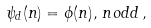Convert formula to latex. <formula><loc_0><loc_0><loc_500><loc_500>\, \psi _ { d } ( n ) = \phi ( n ) , \, n o d d \, ,</formula> 